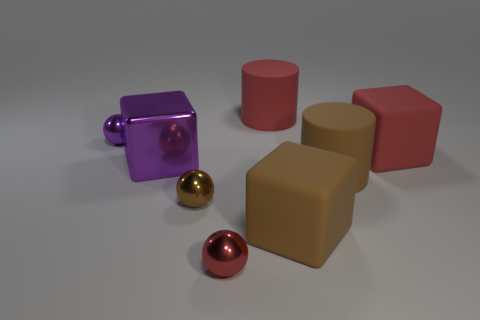What materials do the objects in the image seem to be made of? The objects have a reflective surface which suggests they are made of materials like metal or plastic with a high-gloss finish. 